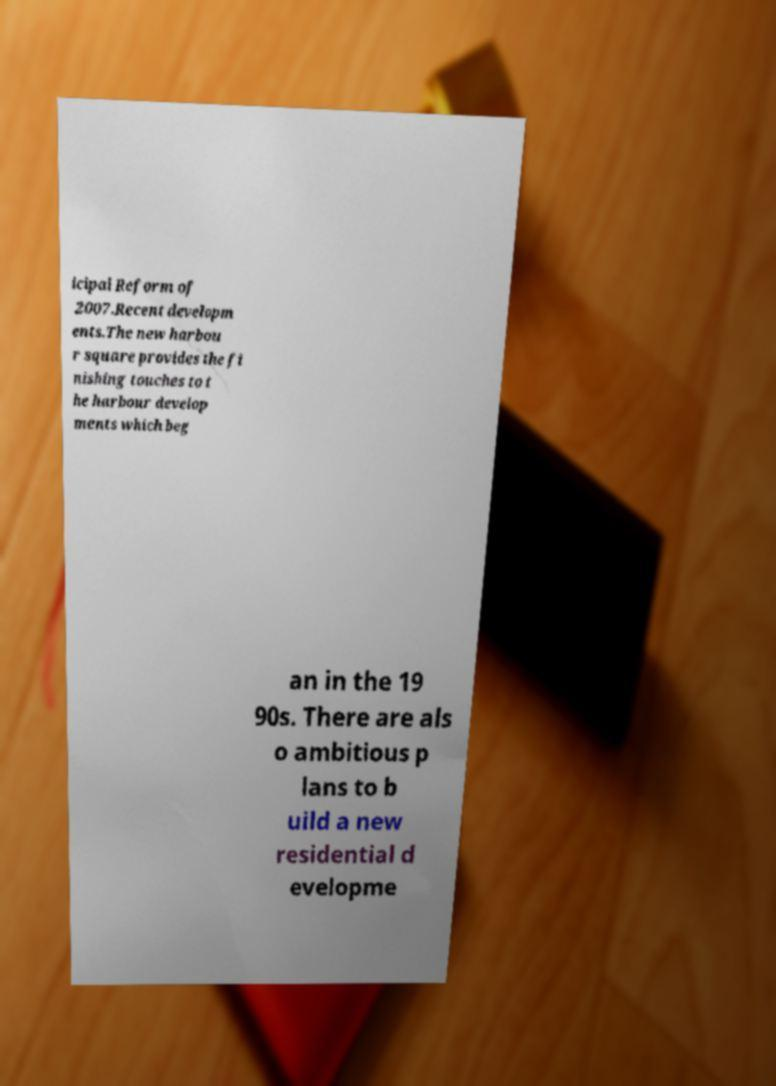Can you accurately transcribe the text from the provided image for me? icipal Reform of 2007.Recent developm ents.The new harbou r square provides the fi nishing touches to t he harbour develop ments which beg an in the 19 90s. There are als o ambitious p lans to b uild a new residential d evelopme 